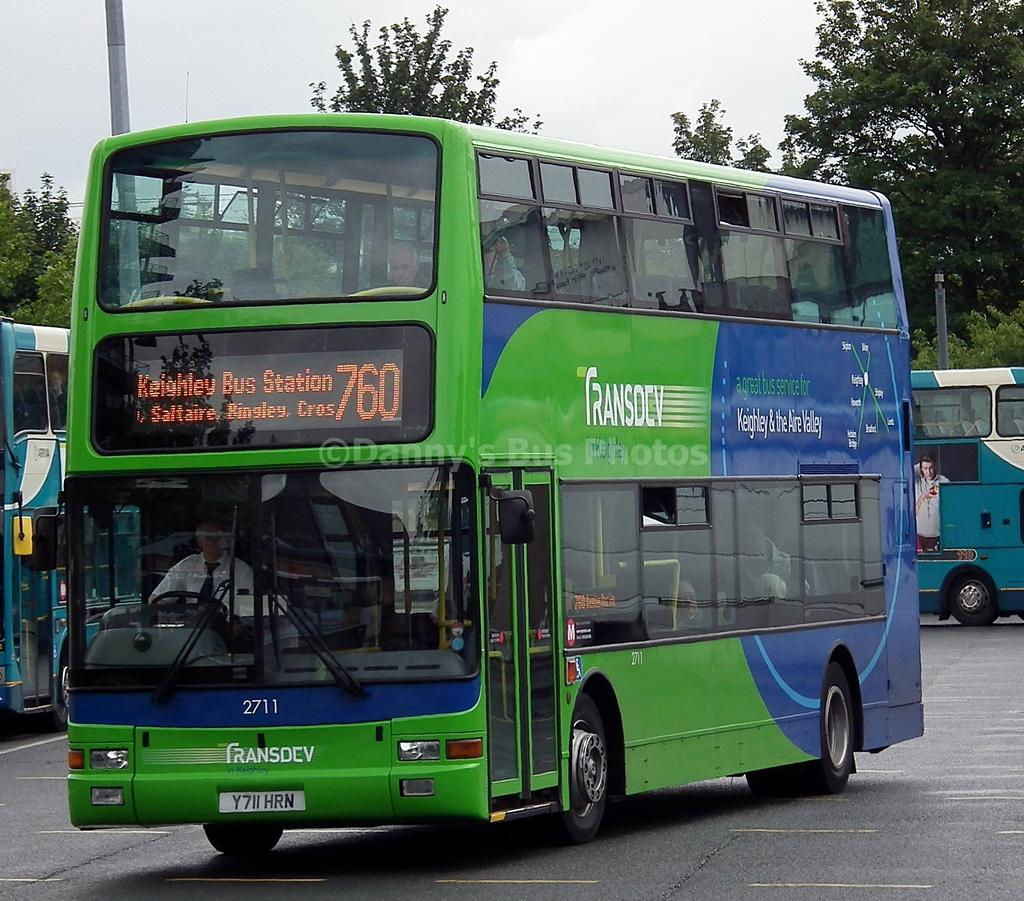What is the main subject of the image? There is a bus in the image. What is the bus doing in the image? The bus is moving on a road. What can be seen in the background of the image? There are bushes, trees, and the sky visible in the background of the image. Can you tell me how many people are reading books on the boat in the image? There is no boat or people reading books in the image; it features a bus moving on a road. What type of brake system is installed on the bus in the image? The image does not provide enough information to determine the type of brake system installed on the bus. 